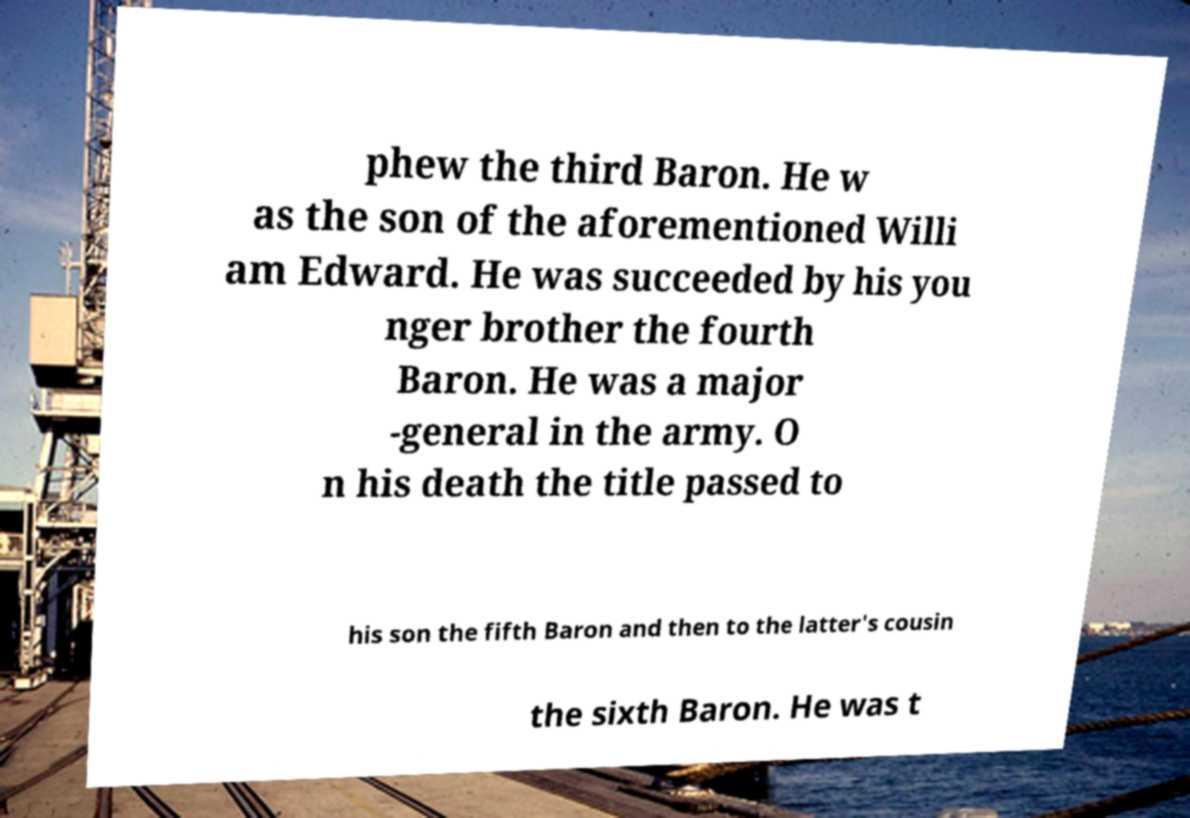Can you read and provide the text displayed in the image?This photo seems to have some interesting text. Can you extract and type it out for me? phew the third Baron. He w as the son of the aforementioned Willi am Edward. He was succeeded by his you nger brother the fourth Baron. He was a major -general in the army. O n his death the title passed to his son the fifth Baron and then to the latter's cousin the sixth Baron. He was t 